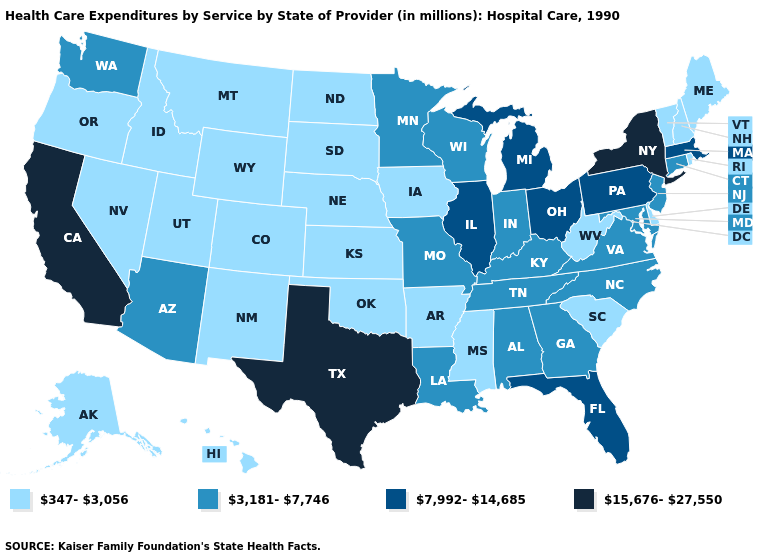Name the states that have a value in the range 15,676-27,550?
Be succinct. California, New York, Texas. What is the value of Missouri?
Short answer required. 3,181-7,746. Name the states that have a value in the range 7,992-14,685?
Write a very short answer. Florida, Illinois, Massachusetts, Michigan, Ohio, Pennsylvania. Which states hav the highest value in the MidWest?
Give a very brief answer. Illinois, Michigan, Ohio. What is the value of Kentucky?
Concise answer only. 3,181-7,746. What is the value of Louisiana?
Short answer required. 3,181-7,746. Name the states that have a value in the range 347-3,056?
Quick response, please. Alaska, Arkansas, Colorado, Delaware, Hawaii, Idaho, Iowa, Kansas, Maine, Mississippi, Montana, Nebraska, Nevada, New Hampshire, New Mexico, North Dakota, Oklahoma, Oregon, Rhode Island, South Carolina, South Dakota, Utah, Vermont, West Virginia, Wyoming. Which states have the highest value in the USA?
Write a very short answer. California, New York, Texas. Does California have the highest value in the West?
Keep it brief. Yes. What is the lowest value in the South?
Be succinct. 347-3,056. Among the states that border South Dakota , does Minnesota have the highest value?
Answer briefly. Yes. Does Idaho have the lowest value in the USA?
Quick response, please. Yes. What is the value of Montana?
Give a very brief answer. 347-3,056. Which states have the lowest value in the USA?
Quick response, please. Alaska, Arkansas, Colorado, Delaware, Hawaii, Idaho, Iowa, Kansas, Maine, Mississippi, Montana, Nebraska, Nevada, New Hampshire, New Mexico, North Dakota, Oklahoma, Oregon, Rhode Island, South Carolina, South Dakota, Utah, Vermont, West Virginia, Wyoming. Name the states that have a value in the range 7,992-14,685?
Keep it brief. Florida, Illinois, Massachusetts, Michigan, Ohio, Pennsylvania. 